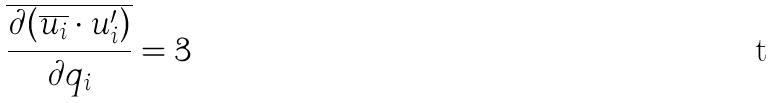Convert formula to latex. <formula><loc_0><loc_0><loc_500><loc_500>\overline { \frac { \partial ( \overline { u _ { i } } \cdot u _ { i } ^ { \prime } ) } { \partial q _ { i } } } = 3</formula> 